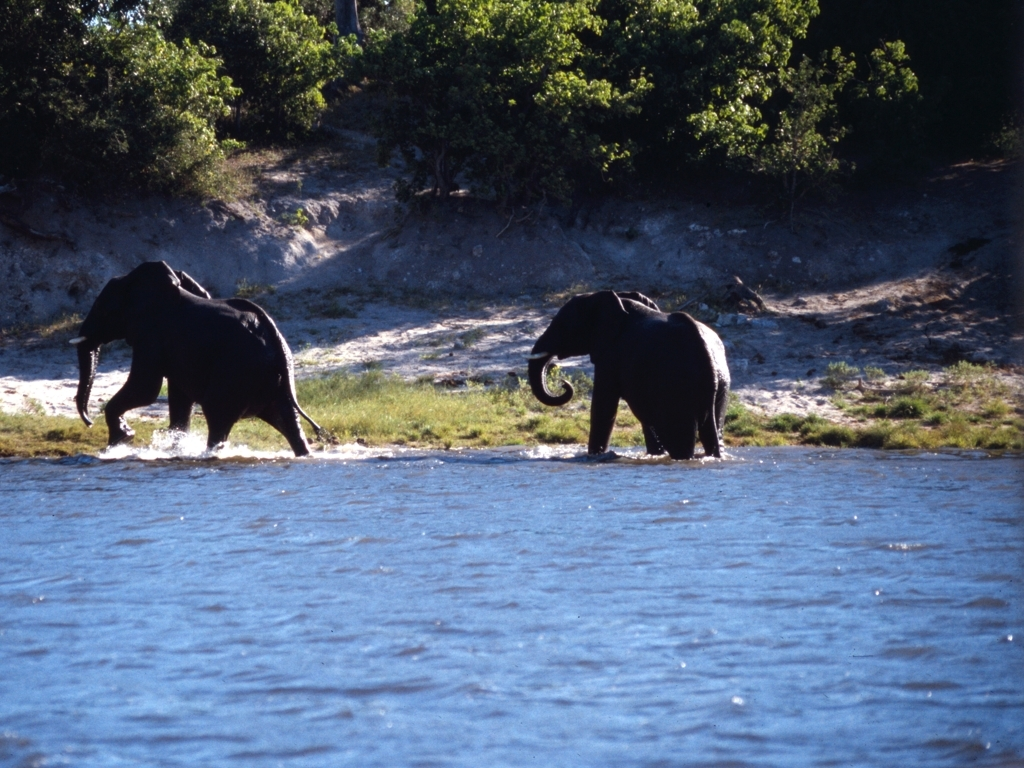What behavior are the elephants exhibiting in the image? The elephants seem to be walking through shallow water, possibly crossing a river or going to or from a watering hole, which is a common behavior in their daily routine for hydration and thermoregulation. 